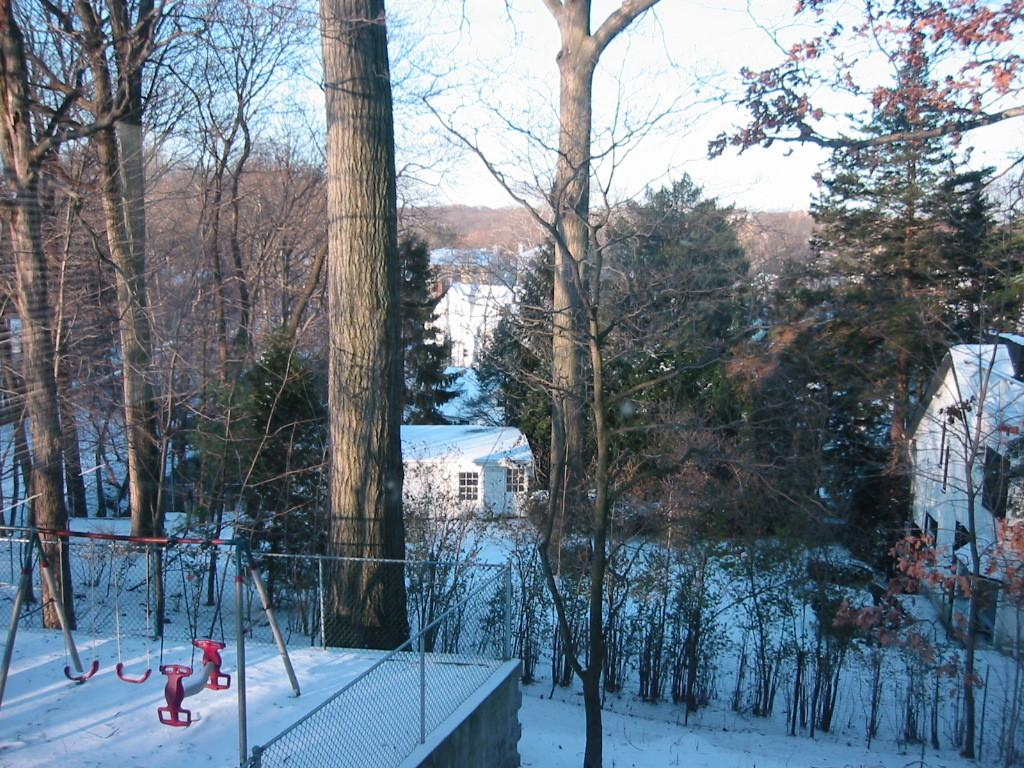What type of playground equipment is visible in the image? There are playground swings in the image. What surrounds the playground swings? The swings are inside a closed metal mesh fencing. What can be seen in the background of the image? There are trees and buildings visible in the image. What is the condition of the surface in the image? The surface of the image has snow. What type of suit is the swing wearing in the image? The swings are not wearing any suits, as they are inanimate objects and cannot wear clothing. 